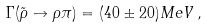<formula> <loc_0><loc_0><loc_500><loc_500>\Gamma ( { \tilde { \rho } } \to \rho \pi ) = ( 4 0 \pm 2 0 ) M e V \, ,</formula> 